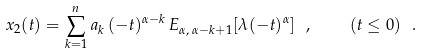Convert formula to latex. <formula><loc_0><loc_0><loc_500><loc_500>x _ { 2 } ( t ) = \sum _ { k = 1 } ^ { n } a _ { k } \, ( - t ) ^ { \alpha - k } \, E _ { \alpha , \, \alpha - k + 1 } [ \lambda ( - t ) ^ { \alpha } ] \ , \quad ( t \leq 0 ) \ . \</formula> 